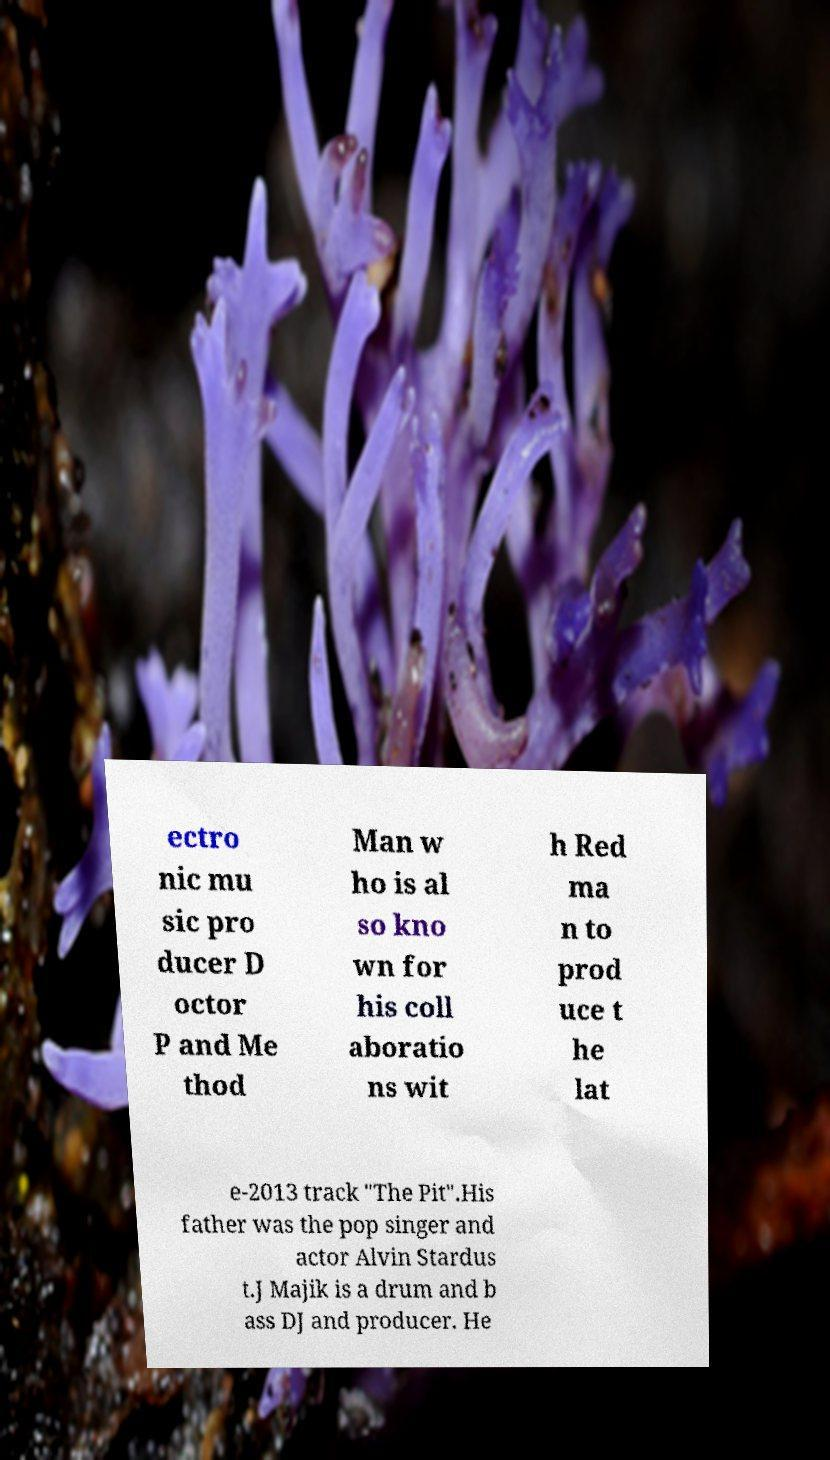Could you assist in decoding the text presented in this image and type it out clearly? ectro nic mu sic pro ducer D octor P and Me thod Man w ho is al so kno wn for his coll aboratio ns wit h Red ma n to prod uce t he lat e-2013 track "The Pit".His father was the pop singer and actor Alvin Stardus t.J Majik is a drum and b ass DJ and producer. He 